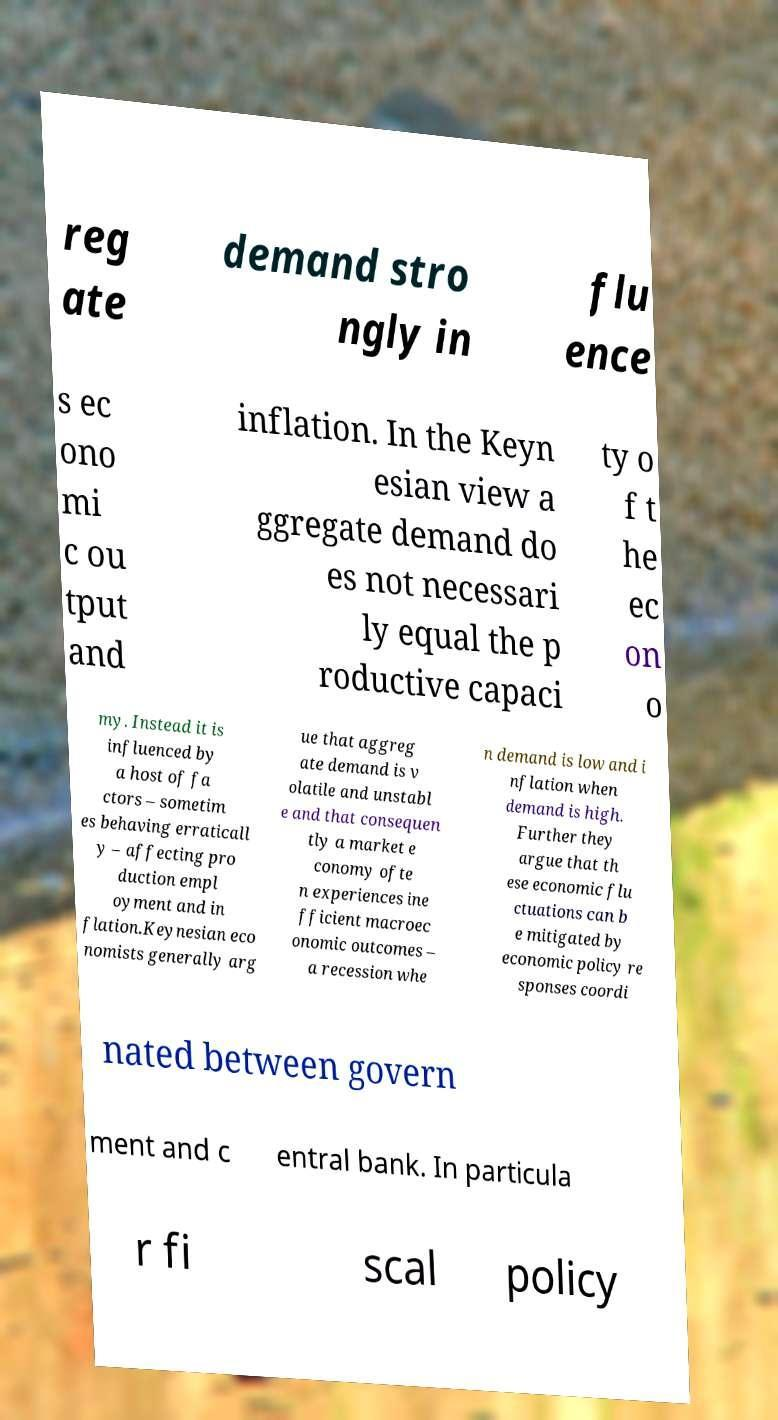Please read and relay the text visible in this image. What does it say? reg ate demand stro ngly in flu ence s ec ono mi c ou tput and inflation. In the Keyn esian view a ggregate demand do es not necessari ly equal the p roductive capaci ty o f t he ec on o my. Instead it is influenced by a host of fa ctors – sometim es behaving erraticall y – affecting pro duction empl oyment and in flation.Keynesian eco nomists generally arg ue that aggreg ate demand is v olatile and unstabl e and that consequen tly a market e conomy ofte n experiences ine fficient macroec onomic outcomes – a recession whe n demand is low and i nflation when demand is high. Further they argue that th ese economic flu ctuations can b e mitigated by economic policy re sponses coordi nated between govern ment and c entral bank. In particula r fi scal policy 